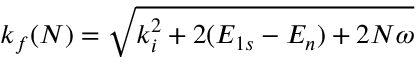<formula> <loc_0><loc_0><loc_500><loc_500>k _ { f } ( N ) = \sqrt { k _ { i } ^ { 2 } + 2 ( E _ { 1 s } - E _ { n } ) + 2 N \omega }</formula> 